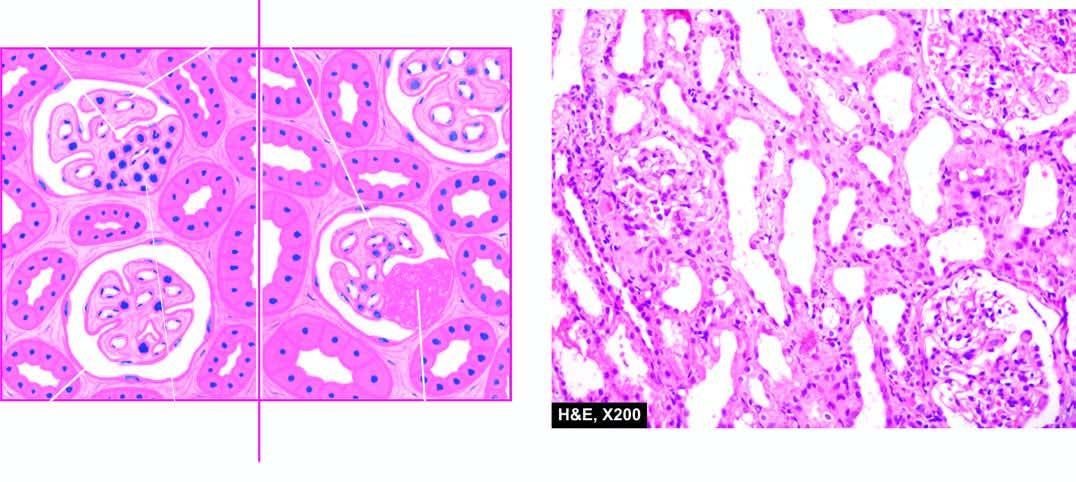how are the features focal and segmental involvement of the glomeruli?
Answer the question using a single word or phrase. By sclerosis and hyalinosis and mesangial hypercellularity 